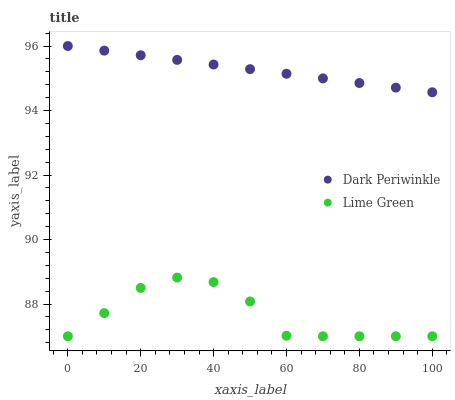Does Lime Green have the minimum area under the curve?
Answer yes or no. Yes. Does Dark Periwinkle have the maximum area under the curve?
Answer yes or no. Yes. Does Dark Periwinkle have the minimum area under the curve?
Answer yes or no. No. Is Dark Periwinkle the smoothest?
Answer yes or no. Yes. Is Lime Green the roughest?
Answer yes or no. Yes. Is Dark Periwinkle the roughest?
Answer yes or no. No. Does Lime Green have the lowest value?
Answer yes or no. Yes. Does Dark Periwinkle have the lowest value?
Answer yes or no. No. Does Dark Periwinkle have the highest value?
Answer yes or no. Yes. Is Lime Green less than Dark Periwinkle?
Answer yes or no. Yes. Is Dark Periwinkle greater than Lime Green?
Answer yes or no. Yes. Does Lime Green intersect Dark Periwinkle?
Answer yes or no. No. 